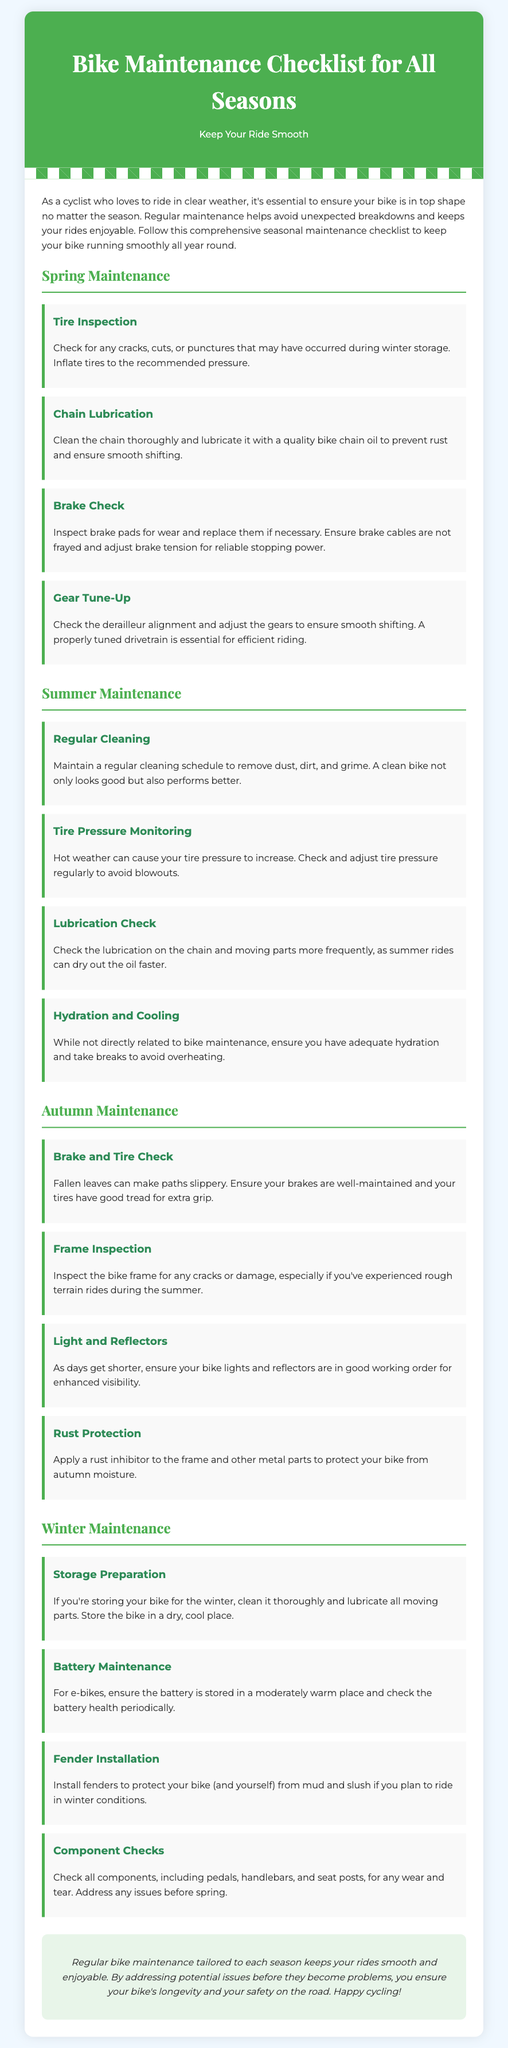What is the title of the document? The title of the document is presented in the header section, prominently displayed.
Answer: Bike Maintenance Checklist for All Seasons How many maintenance seasons are covered? The document lists four distinct seasons for maintenance.
Answer: Four What should you check for in tire inspection during spring? This check specifies the conditions that tires should be in after winter storage.
Answer: Cracks, cuts, or punctures What is responsible for ensuring smooth shifting according to the spring checklist? This information pertains to the maintenance of a specific bike component to keep it functional.
Answer: Gear tune-up What should you ensure works well as days get shorter in autumn? This statement connects to maintaining visibility while riding during decreased daylight hours.
Answer: Bike lights and reflectors How often should you check chain lubrication during summer? The document mentions this maintenance should occur with increased frequency in summer.
Answer: More frequently What should be done to the bike before storing it for winter? This process involves preparing the bike for a dormant period to prevent damage.
Answer: Clean and lubricate Which aspect of maintenance is highlighted for e-bikes in winter? The document emphasizes the care needed for a specific battery component.
Answer: Battery maintenance What is the conclusion of the maintenance checklist? This summarizes the overall benefit of the regular bike maintenance discussed.
Answer: Keeps your rides smooth and enjoyable 